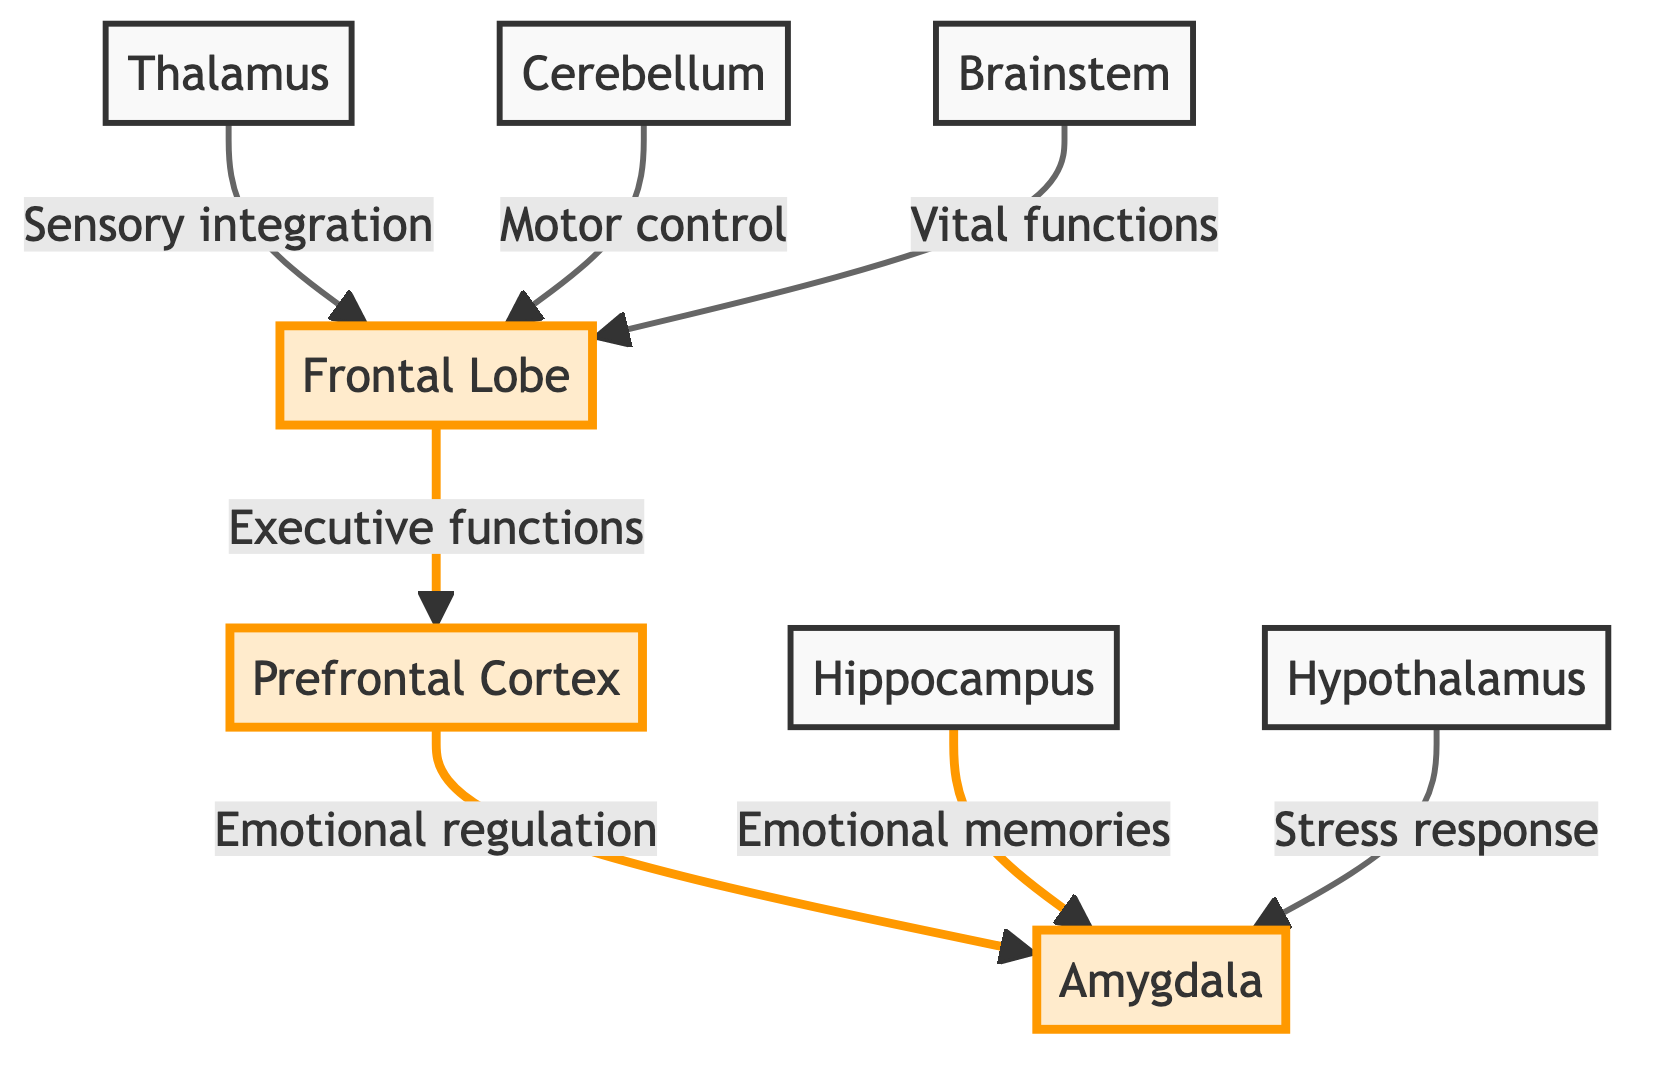What is the highlighted area that regulates emotional responses? The diagram shows the Amygdala as the highlighted area responsible for emotional responses. Highlighting indicates its importance in mental health.
Answer: Amygdala How many main brain regions are highlighted in the diagram? The diagram highlights three main regions: Frontal Lobe, Prefrontal Cortex, and Amygdala. By counting the highlighted elements, we find that there are three.
Answer: Three Which brain region is primarily involved in executive functions? The diagram indicates that the Frontal Lobe is connected to executive functions. It is labeled and highlighted, showing its significance in cognitive processes.
Answer: Frontal Lobe What connection leads from the Prefrontal Cortex to the Amygdala? The connection from the Prefrontal Cortex to the Amygdala is labeled as "Emotional regulation," indicating the role of the Prefrontal Cortex in modulating emotions processed by the Amygdala.
Answer: Emotional regulation Which brain region is associated with emotional memories? The diagram shows the Hippocampus as a key area linked to emotional memories that relate to the Amygdala, thereby addressing the influence of memories on emotional responses.
Answer: Hippocampus What role does the Hypothalamus play in mental health according to the diagram? The diagram connects the Hypothalamus to the Amygdala with the label "Stress response," indicating its involvement in managing stress, which can affect mental health.
Answer: Stress response How does the Thalamus relate to the Frontal Lobe in terms of function? The diagram connects the Thalamus and the Frontal Lobe, indicating that the Thalamus is involved in sensory integration, which provides necessary information for the executive functions of the Frontal Lobe.
Answer: Sensory integration Which brain region controls vital functions and connects to the Frontal Lobe? The Brainstem, according to the diagram, is connected to the Frontal Lobe with the label "Vital functions," highlighting its essential role in maintaining basic life processes.
Answer: Brainstem What is the general function of the Cerebellum as shown in the diagram? The diagram does not specifically highlight the Cerebellum but indicates it is connected to the Frontal Lobe for "Motor control," suggesting its importance in coordinating movement and overall motor functions.
Answer: Motor control 